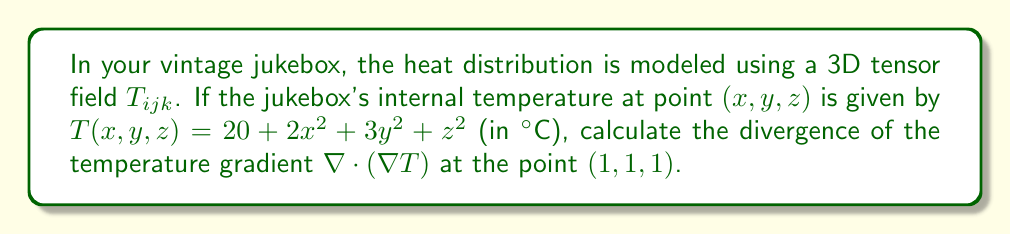Provide a solution to this math problem. To solve this problem, we'll follow these steps:

1) First, we need to find the temperature gradient $\nabla T$. The gradient in 3D is given by:

   $$\nabla T = \left(\frac{\partial T}{\partial x}, \frac{\partial T}{\partial y}, \frac{\partial T}{\partial z}\right)$$

2) Let's calculate each partial derivative:

   $$\frac{\partial T}{\partial x} = 4x$$
   $$\frac{\partial T}{\partial y} = 6y$$
   $$\frac{\partial T}{\partial z} = 2z$$

3) So, the temperature gradient is:

   $$\nabla T = (4x, 6y, 2z)$$

4) Now, we need to calculate the divergence of this gradient. The divergence in 3D is given by:

   $$\nabla \cdot (\nabla T) = \frac{\partial}{\partial x}(4x) + \frac{\partial}{\partial y}(6y) + \frac{\partial}{\partial z}(2z)$$

5) Calculating these derivatives:

   $$\frac{\partial}{\partial x}(4x) = 4$$
   $$\frac{\partial}{\partial y}(6y) = 6$$
   $$\frac{\partial}{\partial z}(2z) = 2$$

6) Adding these up:

   $$\nabla \cdot (\nabla T) = 4 + 6 + 2 = 12$$

7) This result is constant, so it's the same at all points, including (1, 1, 1).
Answer: 12 